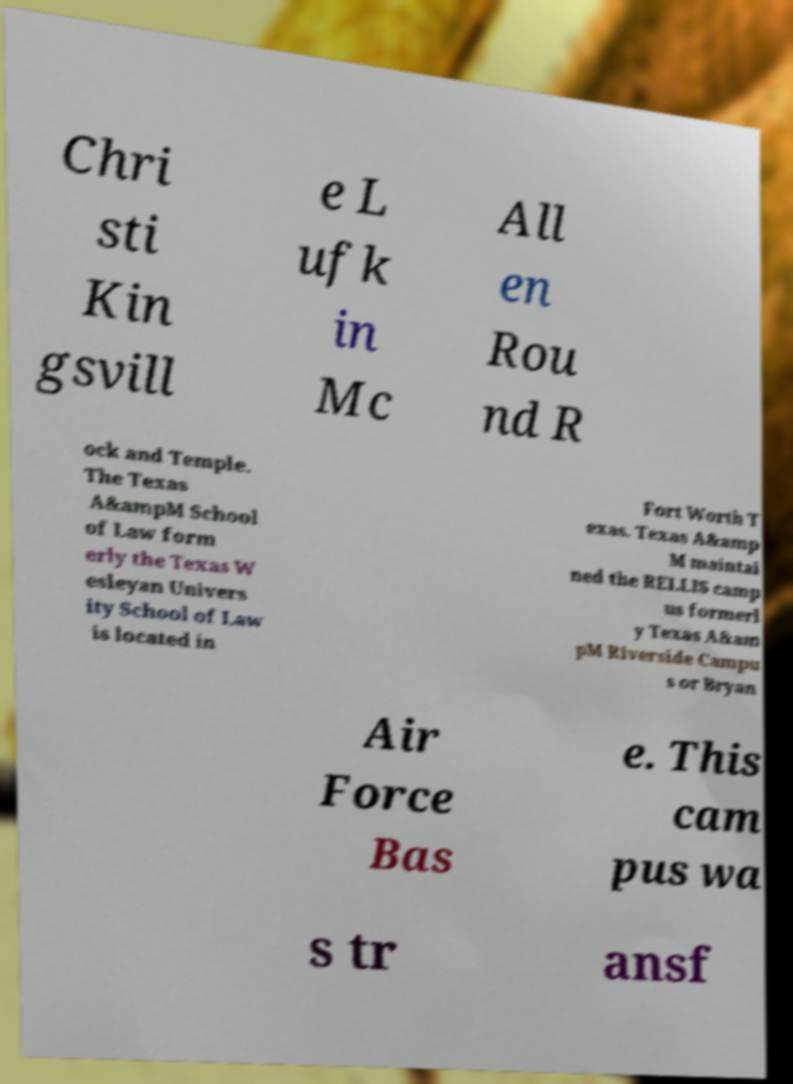Could you extract and type out the text from this image? Chri sti Kin gsvill e L ufk in Mc All en Rou nd R ock and Temple. The Texas A&ampM School of Law form erly the Texas W esleyan Univers ity School of Law is located in Fort Worth T exas. Texas A&amp M maintai ned the RELLIS camp us formerl y Texas A&am pM Riverside Campu s or Bryan Air Force Bas e. This cam pus wa s tr ansf 